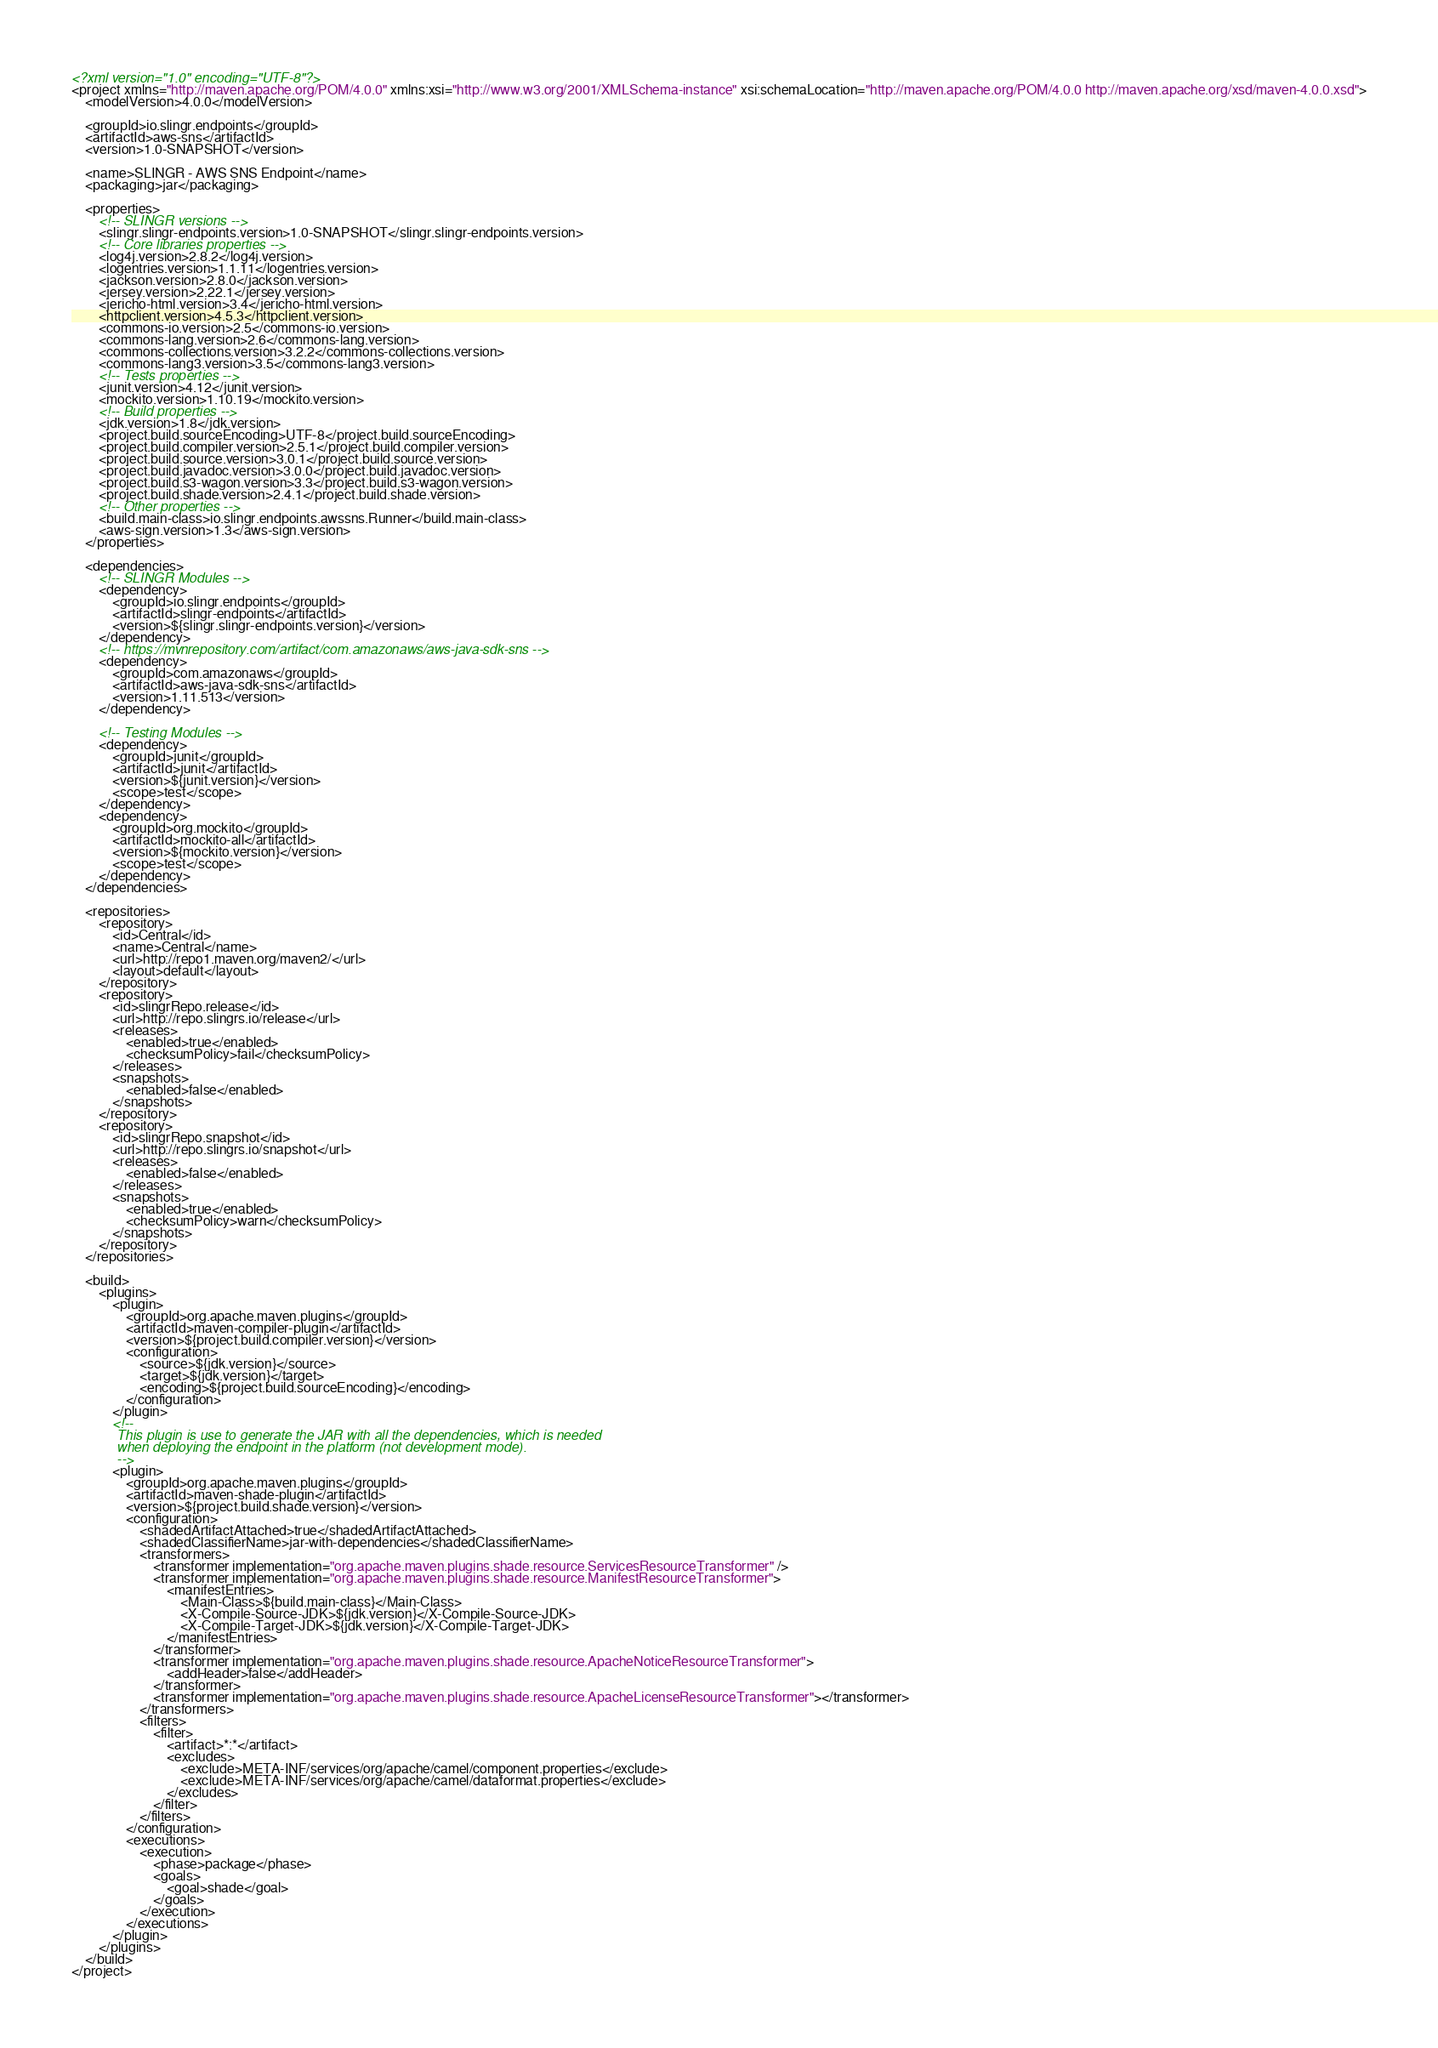Convert code to text. <code><loc_0><loc_0><loc_500><loc_500><_XML_><?xml version="1.0" encoding="UTF-8"?>
<project xmlns="http://maven.apache.org/POM/4.0.0" xmlns:xsi="http://www.w3.org/2001/XMLSchema-instance" xsi:schemaLocation="http://maven.apache.org/POM/4.0.0 http://maven.apache.org/xsd/maven-4.0.0.xsd">
    <modelVersion>4.0.0</modelVersion>

    <groupId>io.slingr.endpoints</groupId>
    <artifactId>aws-sns</artifactId>
    <version>1.0-SNAPSHOT</version>

    <name>SLINGR - AWS SNS Endpoint</name>
    <packaging>jar</packaging>

    <properties>
        <!-- SLINGR versions -->
        <slingr.slingr-endpoints.version>1.0-SNAPSHOT</slingr.slingr-endpoints.version>
        <!-- Core libraries properties -->
        <log4j.version>2.8.2</log4j.version>
        <logentries.version>1.1.11</logentries.version>
        <jackson.version>2.8.0</jackson.version>
        <jersey.version>2.22.1</jersey.version>
        <jericho-html.version>3.4</jericho-html.version>
        <httpclient.version>4.5.3</httpclient.version>
        <commons-io.version>2.5</commons-io.version>
        <commons-lang.version>2.6</commons-lang.version>
        <commons-collections.version>3.2.2</commons-collections.version>
        <commons-lang3.version>3.5</commons-lang3.version>
        <!-- Tests properties -->
        <junit.version>4.12</junit.version>
        <mockito.version>1.10.19</mockito.version>
        <!-- Build properties -->
        <jdk.version>1.8</jdk.version>
        <project.build.sourceEncoding>UTF-8</project.build.sourceEncoding>
        <project.build.compiler.version>2.5.1</project.build.compiler.version>
        <project.build.source.version>3.0.1</project.build.source.version>
        <project.build.javadoc.version>3.0.0</project.build.javadoc.version>
        <project.build.s3-wagon.version>3.3</project.build.s3-wagon.version>
        <project.build.shade.version>2.4.1</project.build.shade.version>
        <!-- Other properties -->
        <build.main-class>io.slingr.endpoints.awssns.Runner</build.main-class>
        <aws-sign.version>1.3</aws-sign.version>
    </properties>

    <dependencies>
        <!-- SLINGR Modules -->
        <dependency>
            <groupId>io.slingr.endpoints</groupId>
            <artifactId>slingr-endpoints</artifactId>
            <version>${slingr.slingr-endpoints.version}</version>
        </dependency>
        <!-- https://mvnrepository.com/artifact/com.amazonaws/aws-java-sdk-sns -->
        <dependency>
            <groupId>com.amazonaws</groupId>
            <artifactId>aws-java-sdk-sns</artifactId>
            <version>1.11.513</version>
        </dependency>

        <!-- Testing Modules -->
        <dependency>
            <groupId>junit</groupId>
            <artifactId>junit</artifactId>
            <version>${junit.version}</version>
            <scope>test</scope>
        </dependency>
        <dependency>
            <groupId>org.mockito</groupId>
            <artifactId>mockito-all</artifactId>
            <version>${mockito.version}</version>
            <scope>test</scope>
        </dependency>
    </dependencies>

    <repositories>
        <repository>
            <id>Central</id>
            <name>Central</name>
            <url>http://repo1.maven.org/maven2/</url>
            <layout>default</layout>
        </repository>
        <repository>
            <id>slingrRepo.release</id>
            <url>http://repo.slingrs.io/release</url>
            <releases>
                <enabled>true</enabled>
                <checksumPolicy>fail</checksumPolicy>
            </releases>
            <snapshots>
                <enabled>false</enabled>
            </snapshots>
        </repository>
        <repository>
            <id>slingrRepo.snapshot</id>
            <url>http://repo.slingrs.io/snapshot</url>
            <releases>
                <enabled>false</enabled>
            </releases>
            <snapshots>
                <enabled>true</enabled>
                <checksumPolicy>warn</checksumPolicy>
            </snapshots>
        </repository>
    </repositories>

    <build>
        <plugins>
            <plugin>
                <groupId>org.apache.maven.plugins</groupId>
                <artifactId>maven-compiler-plugin</artifactId>
                <version>${project.build.compiler.version}</version>
                <configuration>
                    <source>${jdk.version}</source>
                    <target>${jdk.version}</target>
                    <encoding>${project.build.sourceEncoding}</encoding>
                </configuration>
            </plugin>
            <!--
            This plugin is use to generate the JAR with all the dependencies, which is needed
            when deploying the endpoint in the platform (not development mode).
            -->
            <plugin>
                <groupId>org.apache.maven.plugins</groupId>
                <artifactId>maven-shade-plugin</artifactId>
                <version>${project.build.shade.version}</version>
                <configuration>
                    <shadedArtifactAttached>true</shadedArtifactAttached>
                    <shadedClassifierName>jar-with-dependencies</shadedClassifierName>
                    <transformers>
                        <transformer implementation="org.apache.maven.plugins.shade.resource.ServicesResourceTransformer" />
                        <transformer implementation="org.apache.maven.plugins.shade.resource.ManifestResourceTransformer">
                            <manifestEntries>
                                <Main-Class>${build.main-class}</Main-Class>
                                <X-Compile-Source-JDK>${jdk.version}</X-Compile-Source-JDK>
                                <X-Compile-Target-JDK>${jdk.version}</X-Compile-Target-JDK>
                            </manifestEntries>
                        </transformer>
                        <transformer implementation="org.apache.maven.plugins.shade.resource.ApacheNoticeResourceTransformer">
                            <addHeader>false</addHeader>
                        </transformer>
                        <transformer implementation="org.apache.maven.plugins.shade.resource.ApacheLicenseResourceTransformer"></transformer>
                    </transformers>
                    <filters>
                        <filter>
                            <artifact>*:*</artifact>
                            <excludes>
                                <exclude>META-INF/services/org/apache/camel/component.properties</exclude>
                                <exclude>META-INF/services/org/apache/camel/dataformat.properties</exclude>
                            </excludes>
                        </filter>
                    </filters>
                </configuration>
                <executions>
                    <execution>
                        <phase>package</phase>
                        <goals>
                            <goal>shade</goal>
                        </goals>
                    </execution>
                </executions>
            </plugin>
        </plugins>
    </build>
</project>
</code> 